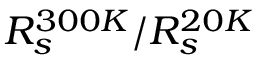<formula> <loc_0><loc_0><loc_500><loc_500>R _ { s } ^ { 3 0 0 K } / R _ { s } ^ { 2 0 K }</formula> 